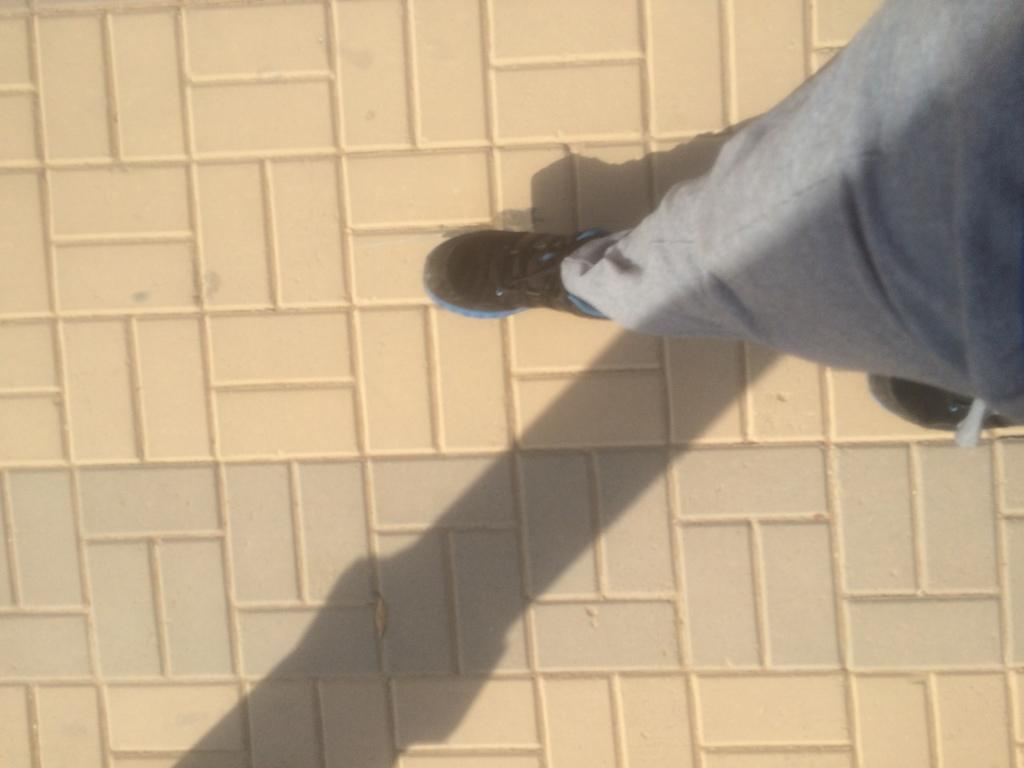What is the main subject of the image? There is a person in the image. Where is the person located in the image? The person is on a path. Can you describe any additional features related to the person in the image? There is a shadow of a person on the path. What is the price of the coat the person is wearing in the image? There is no coat visible in the image, and therefore no price can be determined. 